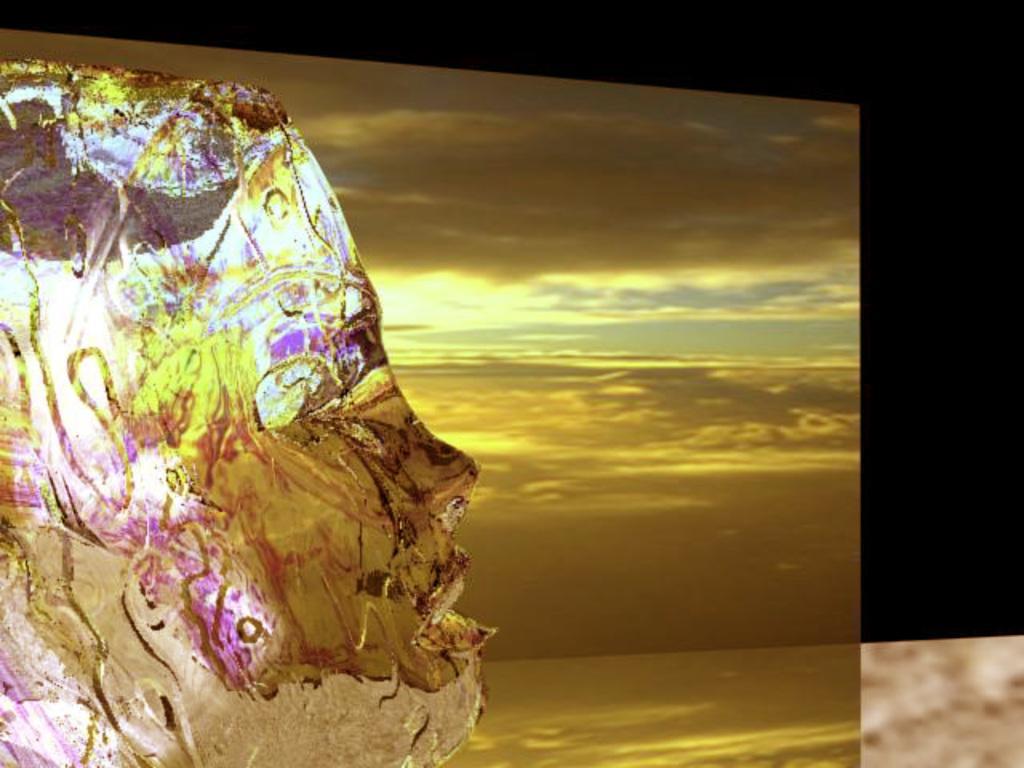Can you describe this image briefly? This is an edited image in this image there is a sculpture, in the background there is a golden sheet and a black sheet. 